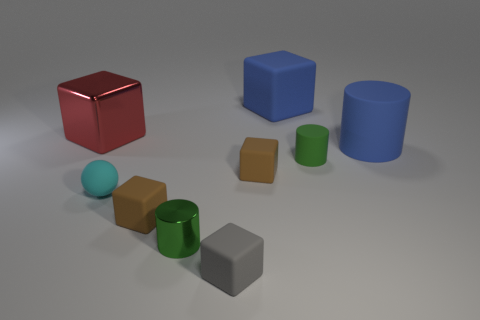Subtract all small cylinders. How many cylinders are left? 1 Subtract 1 spheres. How many spheres are left? 0 Subtract all blue cylinders. How many cylinders are left? 2 Subtract all blocks. How many objects are left? 4 Subtract all yellow cylinders. How many red blocks are left? 1 Add 1 small matte balls. How many small matte balls are left? 2 Add 3 big matte cylinders. How many big matte cylinders exist? 4 Subtract 0 red cylinders. How many objects are left? 9 Subtract all purple balls. Subtract all gray cylinders. How many balls are left? 1 Subtract all yellow objects. Subtract all tiny rubber balls. How many objects are left? 8 